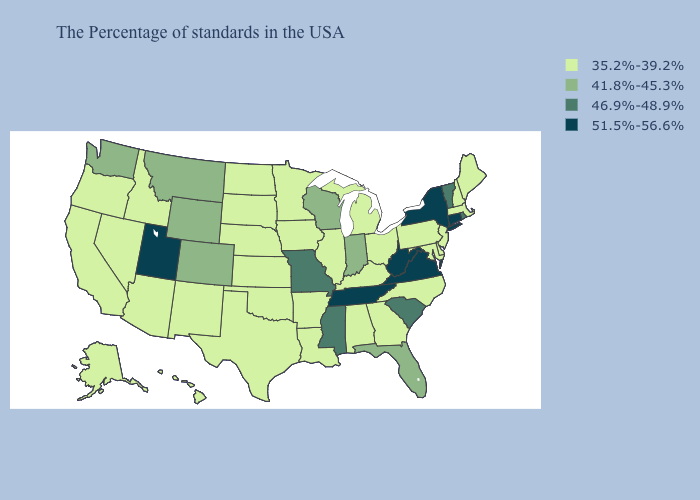Does Texas have a lower value than Ohio?
Be succinct. No. Does Washington have the same value as Arizona?
Write a very short answer. No. What is the value of Arizona?
Keep it brief. 35.2%-39.2%. What is the highest value in the Northeast ?
Short answer required. 51.5%-56.6%. What is the value of Hawaii?
Be succinct. 35.2%-39.2%. What is the value of New Mexico?
Write a very short answer. 35.2%-39.2%. What is the lowest value in the USA?
Keep it brief. 35.2%-39.2%. Among the states that border New York , which have the lowest value?
Write a very short answer. Massachusetts, New Jersey, Pennsylvania. What is the value of South Dakota?
Concise answer only. 35.2%-39.2%. What is the value of Iowa?
Be succinct. 35.2%-39.2%. Name the states that have a value in the range 41.8%-45.3%?
Short answer required. Florida, Indiana, Wisconsin, Wyoming, Colorado, Montana, Washington. What is the value of South Dakota?
Keep it brief. 35.2%-39.2%. What is the lowest value in the USA?
Quick response, please. 35.2%-39.2%. Which states have the highest value in the USA?
Be succinct. Connecticut, New York, Virginia, West Virginia, Tennessee, Utah. 